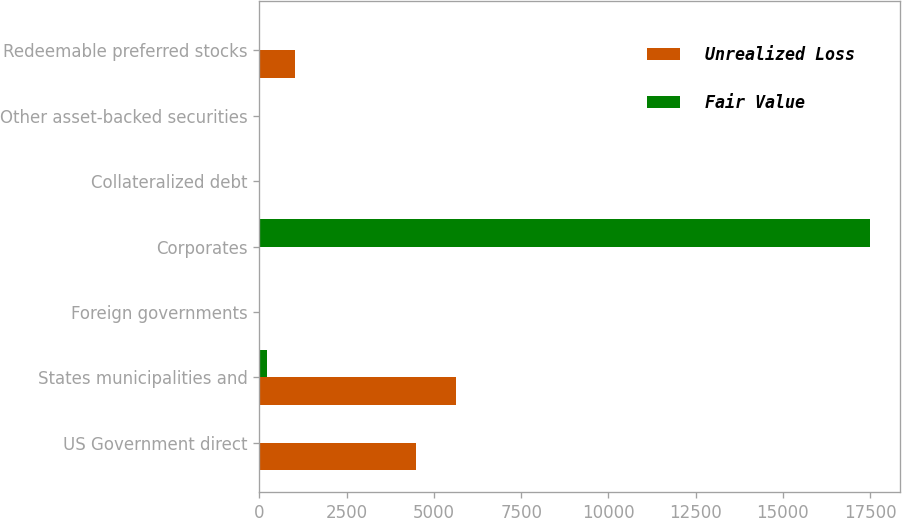<chart> <loc_0><loc_0><loc_500><loc_500><stacked_bar_chart><ecel><fcel>US Government direct<fcel>States municipalities and<fcel>Foreign governments<fcel>Corporates<fcel>Collateralized debt<fcel>Other asset-backed securities<fcel>Redeemable preferred stocks<nl><fcel>Unrealized Loss<fcel>4478<fcel>5632<fcel>0<fcel>1<fcel>0<fcel>0<fcel>1008<nl><fcel>Fair Value<fcel>7<fcel>206<fcel>0<fcel>17491<fcel>0<fcel>0<fcel>1<nl></chart> 